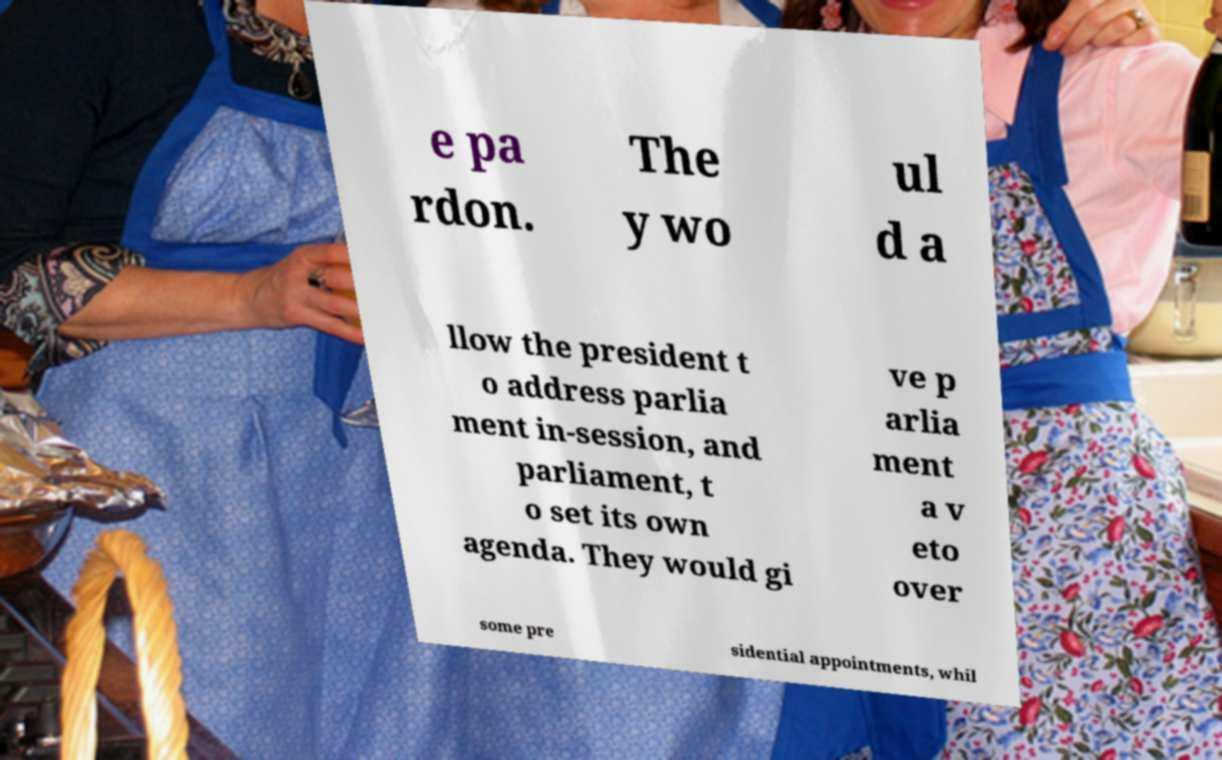Can you read and provide the text displayed in the image?This photo seems to have some interesting text. Can you extract and type it out for me? e pa rdon. The y wo ul d a llow the president t o address parlia ment in-session, and parliament, t o set its own agenda. They would gi ve p arlia ment a v eto over some pre sidential appointments, whil 